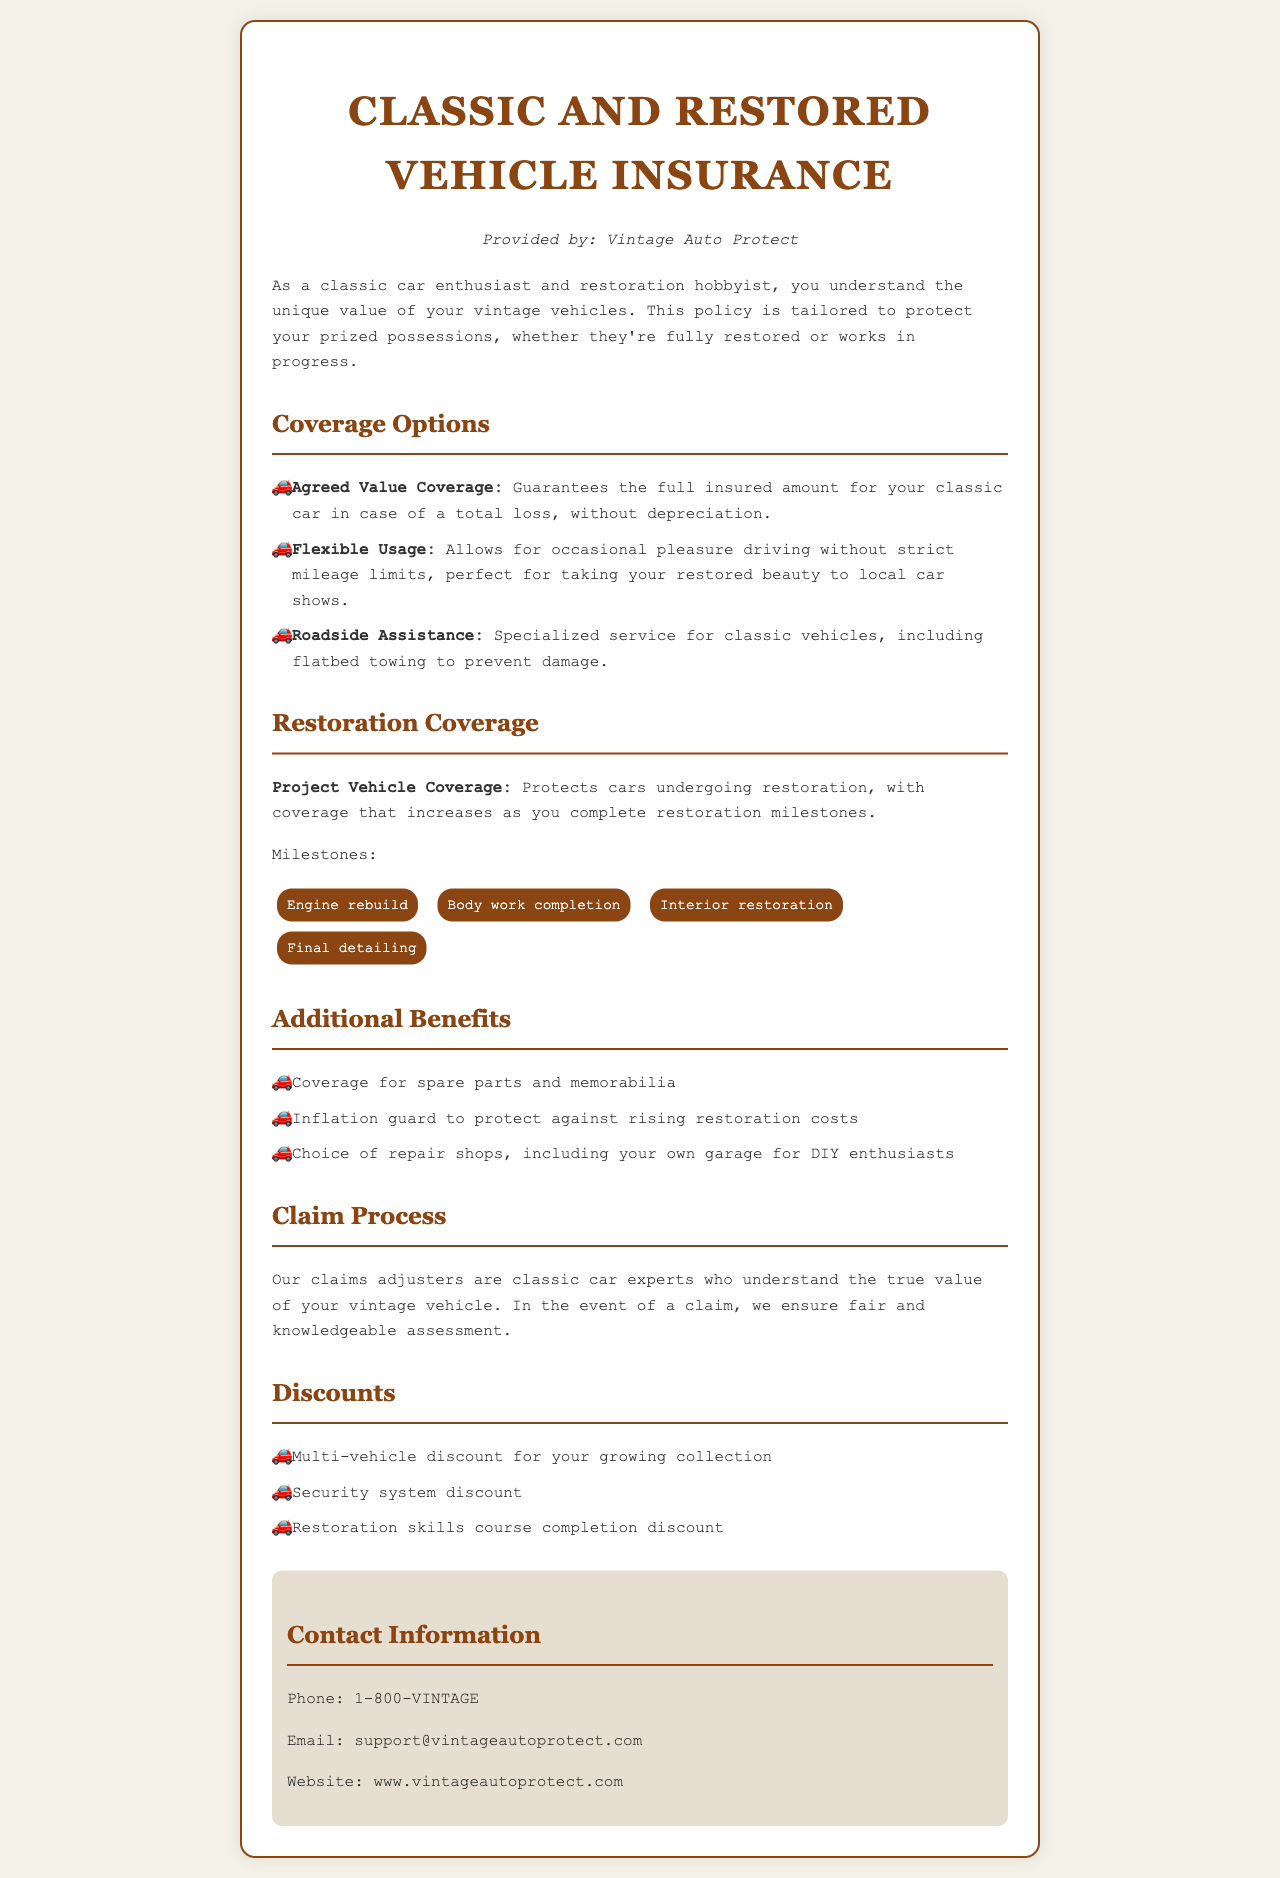What is the name of the insurance provider? The document states that the provider is Vintage Auto Protect.
Answer: Vintage Auto Protect What type of coverage guarantees full insured amount without depreciation? The document specifies Agreed Value Coverage as the coverage type that guarantees the full insured amount in case of a total loss without depreciation.
Answer: Agreed Value Coverage What protects cars undergoing restoration? The document mentions Project Vehicle Coverage as the protection for cars undergoing restoration.
Answer: Project Vehicle Coverage How many restoration milestones are listed? The document lists four restoration milestones that increase coverage.
Answer: Four What benefit includes coverage for spare parts? The document outlines one of the additional benefits that includes coverage for spare parts and memorabilia.
Answer: Coverage for spare parts and memorabilia Which discount is available for completing a restoration skills course? The document mentions a Restoration skills course completion discount as a type of discount available.
Answer: Restoration skills course completion discount What does the inflation guard protect against? The inflation guard is designed to protect against rising restoration costs according to the document.
Answer: Rising restoration costs What type of assistance is specialized for classic vehicles? The document indicates Roadside Assistance as the type specialized for classic vehicles.
Answer: Roadside Assistance 